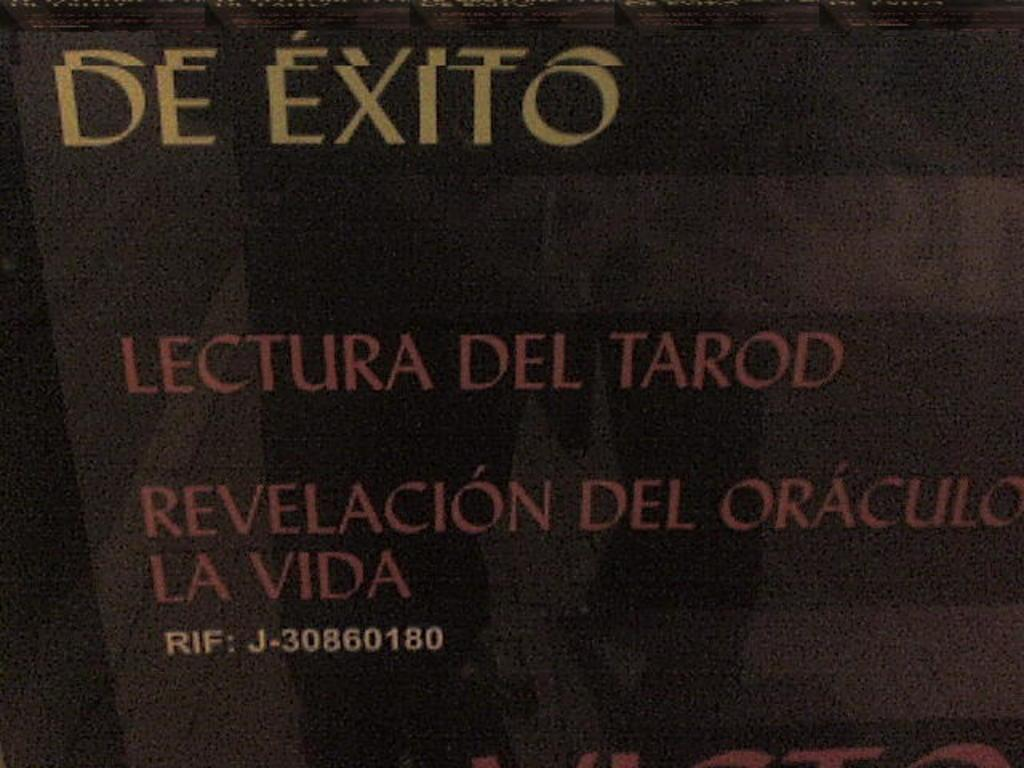<image>
Provide a brief description of the given image. The words De Exito are written on a dark background with some other words in Spanish. 